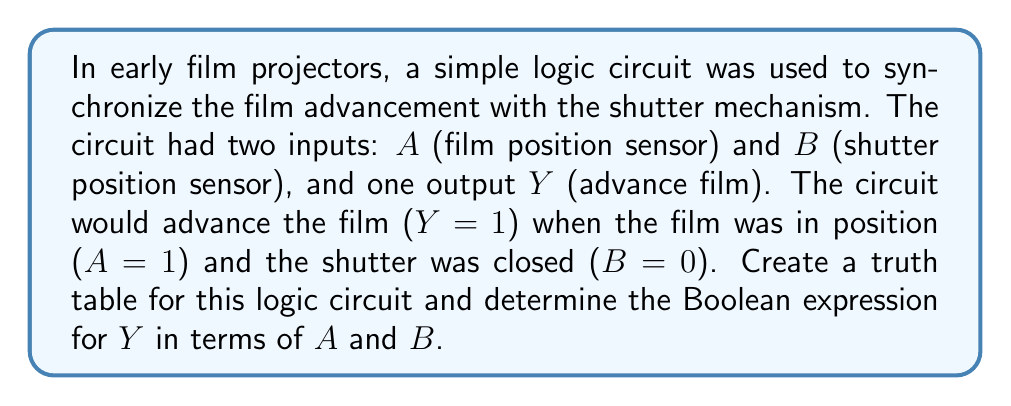Show me your answer to this math problem. Let's approach this step-by-step:

1) First, we need to create a truth table with all possible combinations of inputs $A$ and $B$, and the corresponding output $Y$.

2) We have two inputs, so there are $2^2 = 4$ possible input combinations.

3) Let's create the truth table:

   $A$ | $B$ | $Y$
   ----+-----+----
   0   | 0   | 0
   0   | 1   | 0
   1   | 0   | 1
   1   | 1   | 0

4) Now, we need to determine the Boolean expression for $Y$. We're looking for the condition where $Y=1$.

5) From the truth table, we can see that $Y=1$ only when $A=1$ and $B=0$.

6) In Boolean algebra, this is represented as: $Y = A \cdot \overline{B}$

   Where $\cdot$ represents AND, and $\overline{B}$ represents NOT $B$.

7) This can also be written as: $Y = A \land \lnot B$

   Where $\land$ represents AND, and $\lnot$ represents NOT.
Answer: $Y = A \cdot \overline{B}$ or $Y = A \land \lnot B$ 